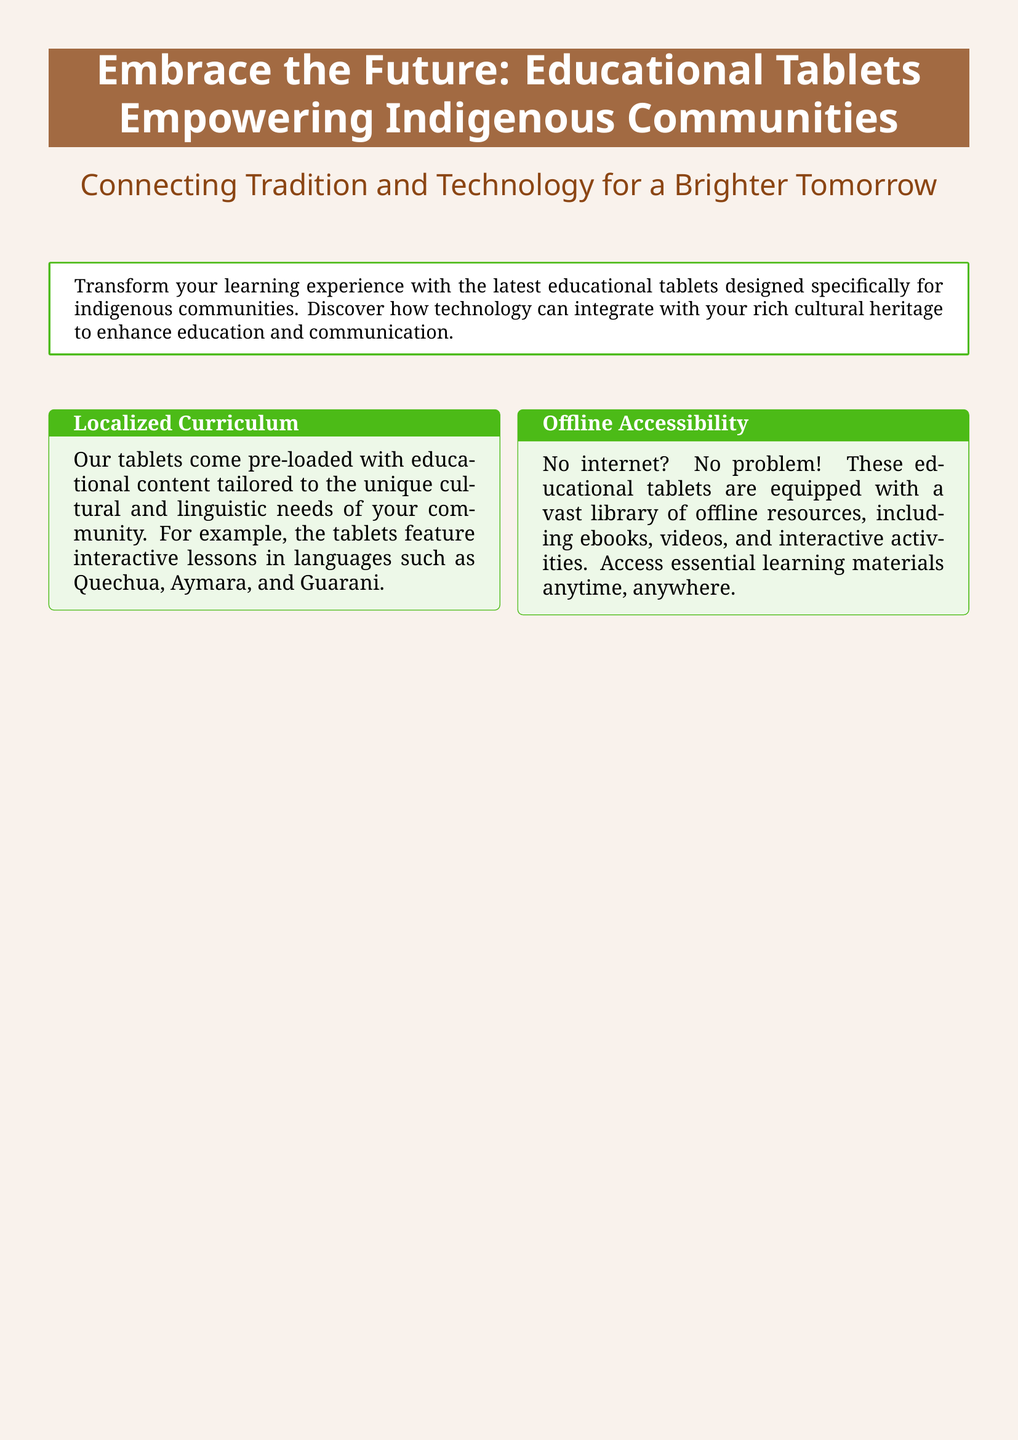What is the primary purpose of the tablets? The tablets are designed to transform learning experiences for indigenous communities by integrating technology with cultural heritage.
Answer: Transform learning experiences Which languages are included in the curriculum? The tablets feature interactive lessons in languages such as Quechua, Aymara, and Guarani.
Answer: Quechua, Aymara, and Guarani What feature allows access to educational content without the internet? The tablets are equipped with a vast library of offline resources, including ebooks, videos, and interactive activities.
Answer: Offline resources How are the tablets described in terms of durability? The tablets are described as designed for rugged conditions and built to withstand challenges of remote environments.
Answer: Durable What has been said about the impact of the educational tablet on the community? Maria Huanca states that the educational tablet has been a game-changer for their community and has helped preserve their language.
Answer: Game-changer for community What is a key feature of the tablets for communication? The tablets include built-in communication tools to share important news, cultural stories, and community events.
Answer: Built-in communication tools What type of learning experience do the tablets promote? The tablets promote interactive learning through lessons and games designed to make learning fun and effective.
Answer: Interactive learning What special charging option do the tablets offer? The tablets offer solar charging options, making them suitable for remote villages.
Answer: Solar charging options 